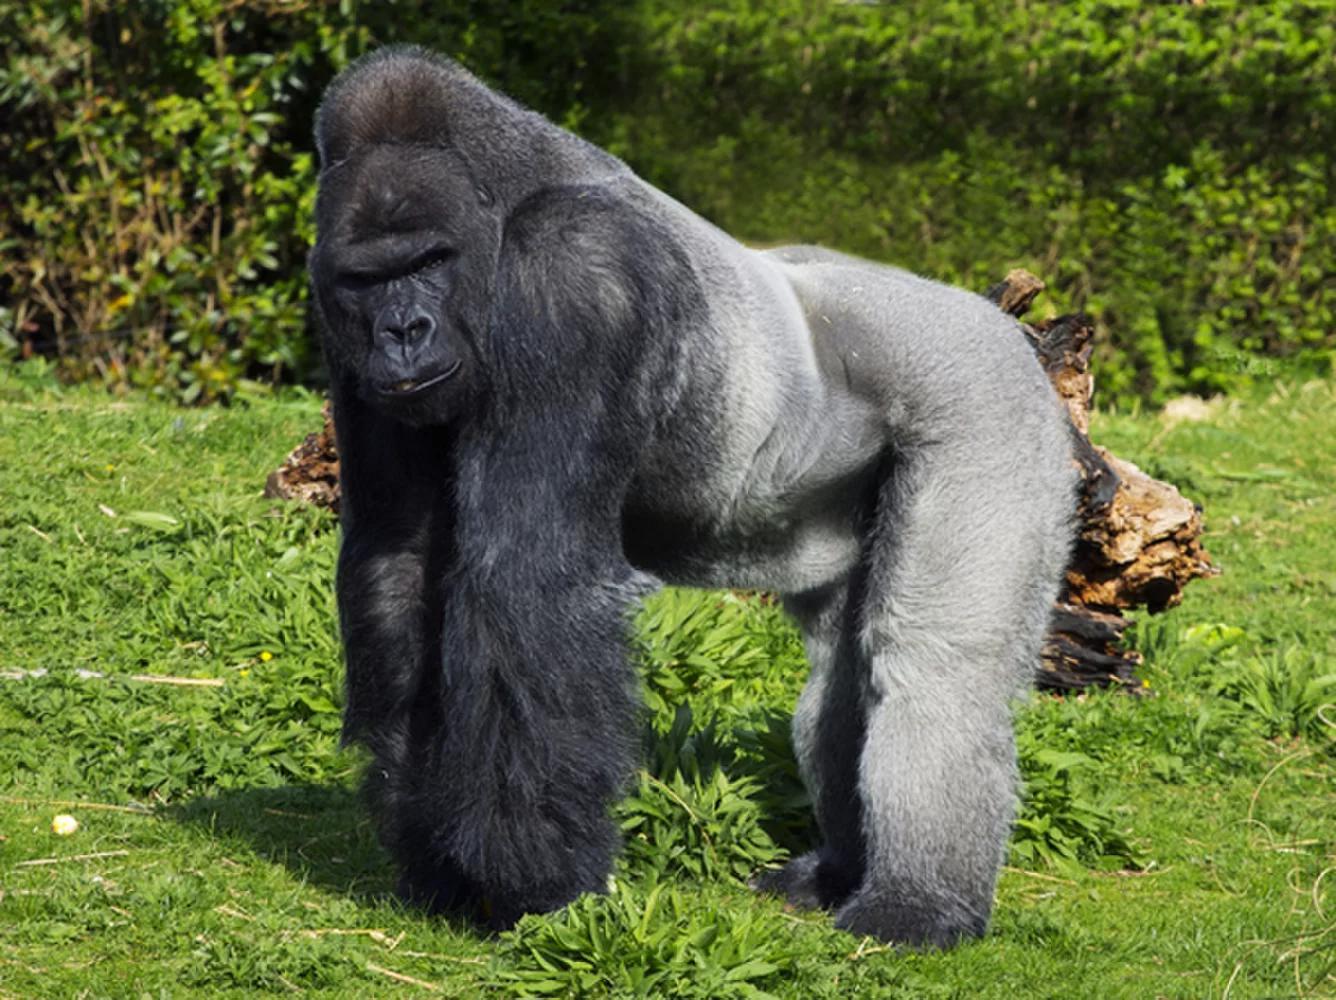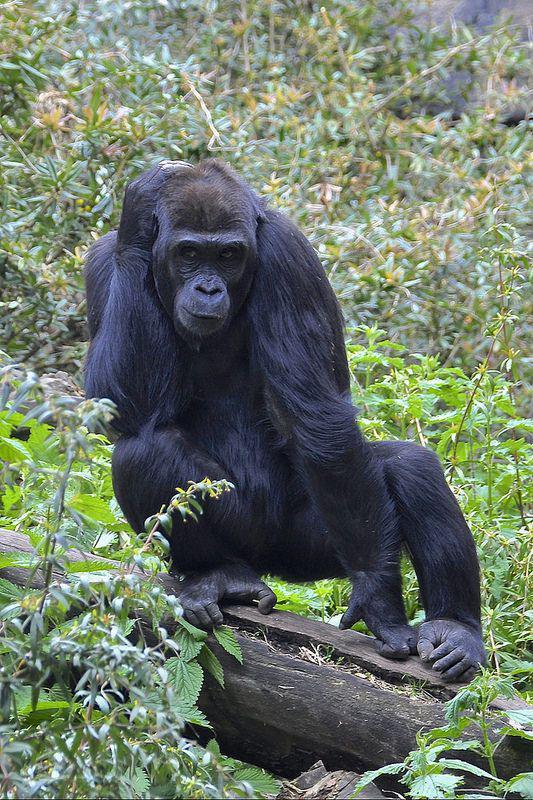The first image is the image on the left, the second image is the image on the right. Evaluate the accuracy of this statement regarding the images: "An image shows a large male gorilla on all fours, with body facing left.". Is it true? Answer yes or no. Yes. The first image is the image on the left, the second image is the image on the right. Considering the images on both sides, is "One of the animals is sitting on the ground." valid? Answer yes or no. No. 